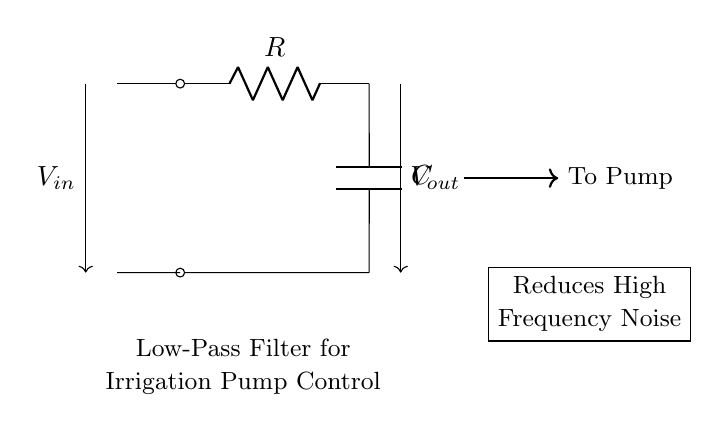What components are present in this circuit? The circuit contains a resistor (R) and a capacitor (C) connected in series to form a low-pass filter.
Answer: Resistor, Capacitor What does the circuit aim to reduce? The low-pass filter is specifically designed to reduce high-frequency noise, which can interfere with the operation of the irrigation pump.
Answer: High-frequency noise What is the type of circuit shown? The circuit is identified as a low-pass filter, which allows low-frequency signals to pass while attenuating high-frequency signals.
Answer: Low-pass filter How is the output voltage related to the input voltage? The output voltage is taken across the capacitor and will be lower than the input voltage due to the filtering effect, particularly at higher frequencies.
Answer: Lower What is the function of the capacitor in this circuit? The capacitor stores energy and helps to smooth out variations in voltage, allowing only lower frequencies to pass through while blocking higher frequencies.
Answer: Smoothing What direction does the current flow in this circuit? The current flows from the input voltage source through the resistor, then into the capacitor, and finally to the output.
Answer: Forward 